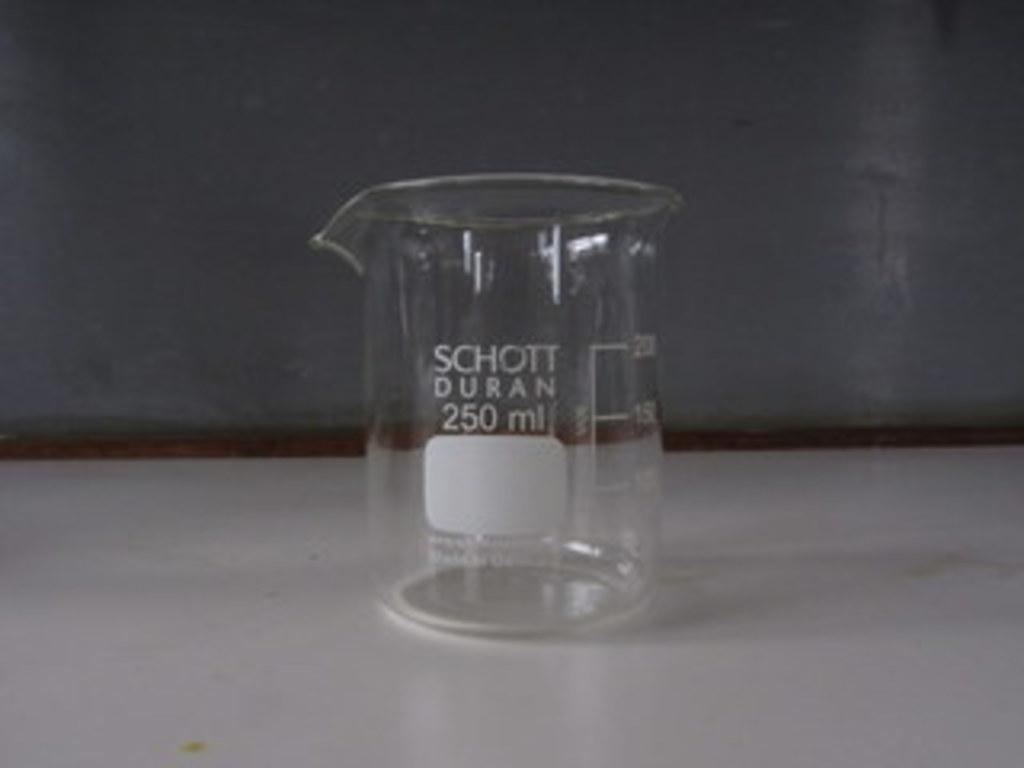<image>
Render a clear and concise summary of the photo. A measuring cup that can hold 250 milliliters 